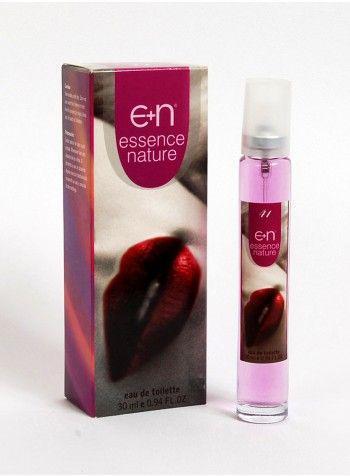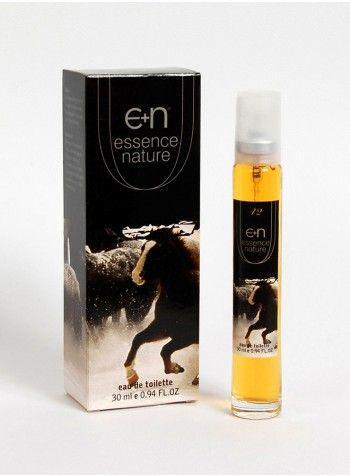The first image is the image on the left, the second image is the image on the right. Assess this claim about the two images: "A pink perfume bottle is next to its box in the left image.". Correct or not? Answer yes or no. Yes. The first image is the image on the left, the second image is the image on the right. Considering the images on both sides, is "An image shows a product with a galloping horse on the front of the package." valid? Answer yes or no. Yes. 